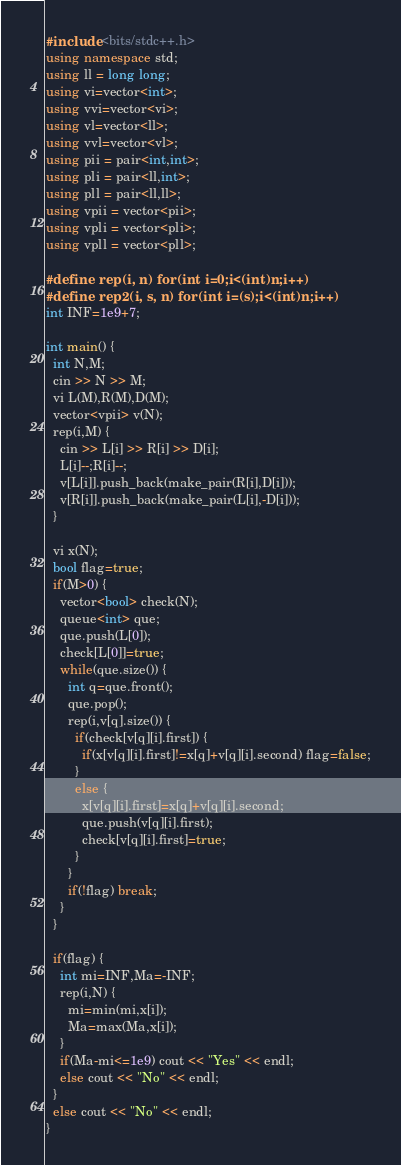Convert code to text. <code><loc_0><loc_0><loc_500><loc_500><_C++_>#include <bits/stdc++.h>
using namespace std;
using ll = long long;
using vi=vector<int>;
using vvi=vector<vi>;
using vl=vector<ll>;
using vvl=vector<vl>;
using pii = pair<int,int>;
using pli = pair<ll,int>;
using pll = pair<ll,ll>;
using vpii = vector<pii>;
using vpli = vector<pli>;
using vpll = vector<pll>;

#define rep(i, n) for(int i=0;i<(int)n;i++)
#define rep2(i, s, n) for(int i=(s);i<(int)n;i++)
int INF=1e9+7;

int main() {
  int N,M;
  cin >> N >> M;
  vi L(M),R(M),D(M);
  vector<vpii> v(N);
  rep(i,M) {
    cin >> L[i] >> R[i] >> D[i];
    L[i]--;R[i]--;
    v[L[i]].push_back(make_pair(R[i],D[i]));
    v[R[i]].push_back(make_pair(L[i],-D[i]));
  }
  
  vi x(N);
  bool flag=true;
  if(M>0) {
    vector<bool> check(N);
    queue<int> que;
    que.push(L[0]);
    check[L[0]]=true;
    while(que.size()) {
      int q=que.front();
      que.pop();
      rep(i,v[q].size()) {
        if(check[v[q][i].first]) {
          if(x[v[q][i].first]!=x[q]+v[q][i].second) flag=false;
        }
        else {
          x[v[q][i].first]=x[q]+v[q][i].second;
          que.push(v[q][i].first);
          check[v[q][i].first]=true;
        }
      }
      if(!flag) break;
    }
  }
  
  if(flag) {
    int mi=INF,Ma=-INF;
    rep(i,N) {
      mi=min(mi,x[i]);
      Ma=max(Ma,x[i]);
    }
    if(Ma-mi<=1e9) cout << "Yes" << endl;
    else cout << "No" << endl;
  }
  else cout << "No" << endl;
}</code> 